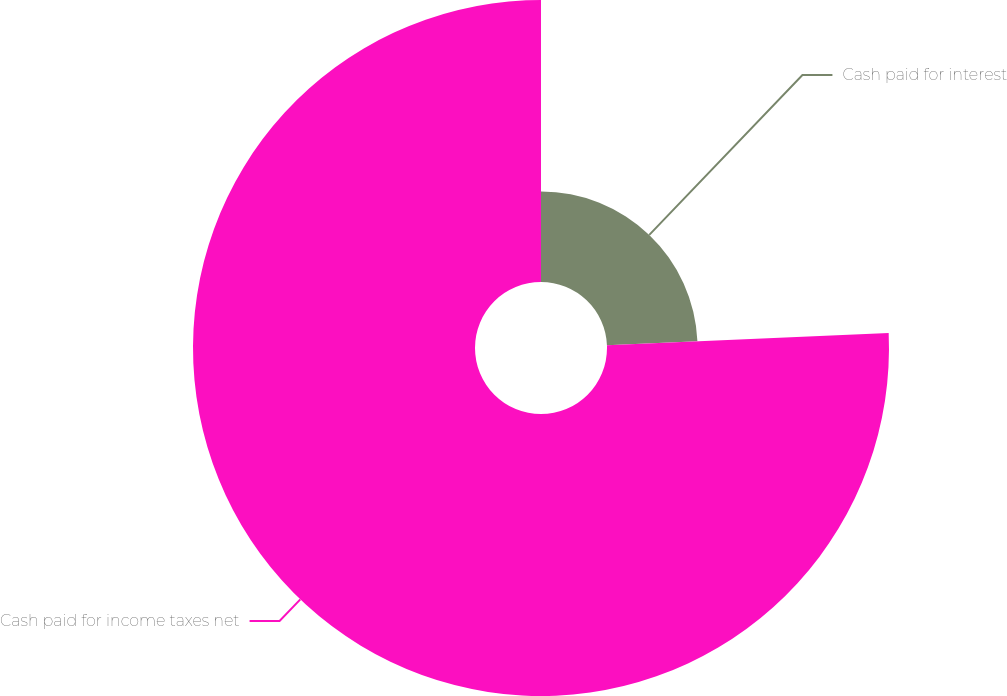<chart> <loc_0><loc_0><loc_500><loc_500><pie_chart><fcel>Cash paid for interest<fcel>Cash paid for income taxes net<nl><fcel>24.31%<fcel>75.69%<nl></chart> 